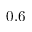Convert formula to latex. <formula><loc_0><loc_0><loc_500><loc_500>0 . 6</formula> 